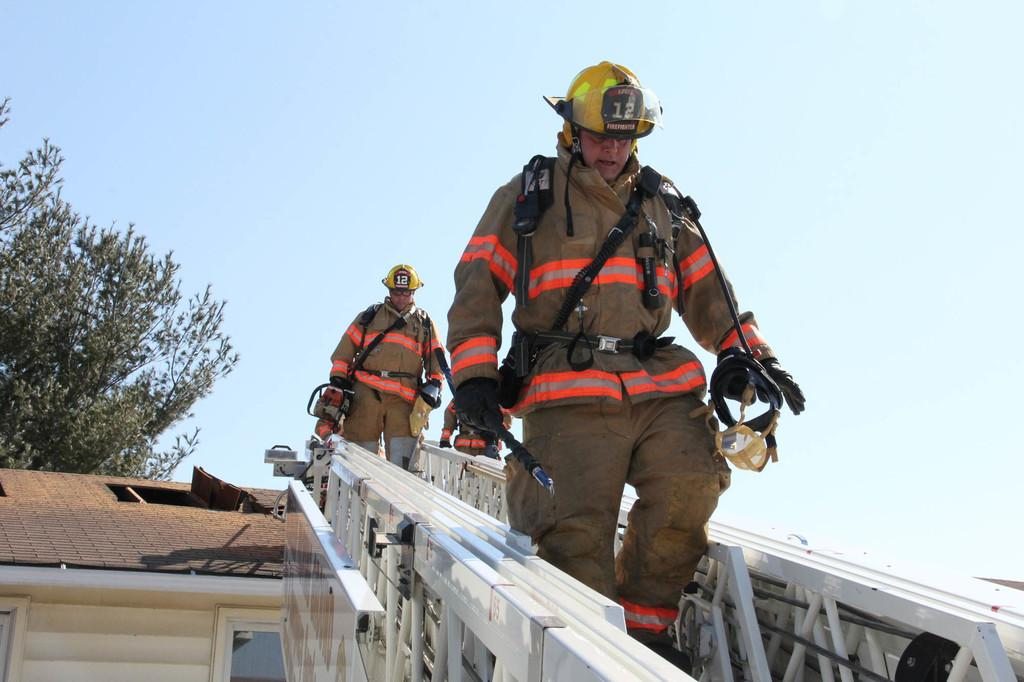What are the people in the image wearing? The people in the image are wearing uniforms and helmets. What activity are the people engaged in? The people are walking on a ladder. What can be seen in the background of the image? There is a wooden house and a tree in the background of the image. What is visible in the sky in the image? The sky is visible in the background of the image. How many pins are holding the ladder to the tree in the image? There are no pins visible in the image, nor is the ladder attached to a tree. What type of hen can be seen roosting on the roof of the wooden house in the image? There is no hen present in the image; only a wooden house and a tree are visible in the background. 